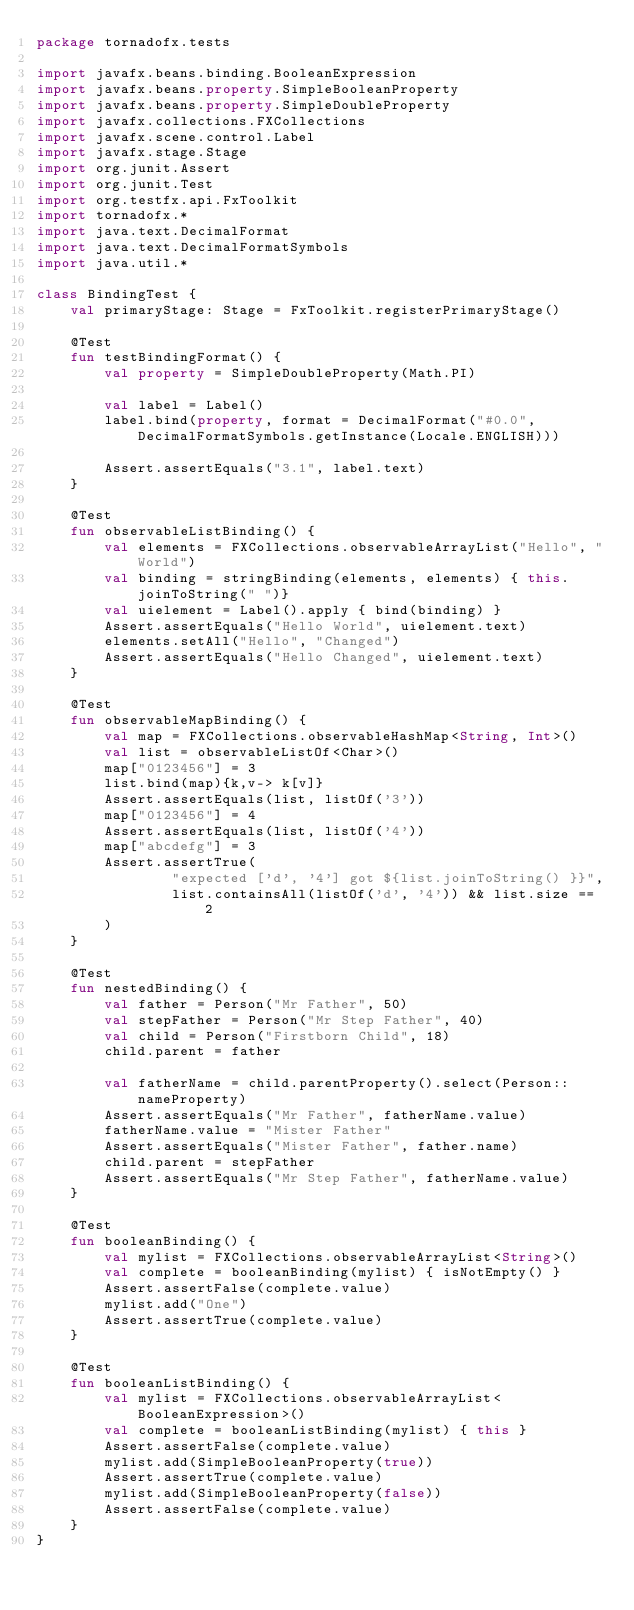<code> <loc_0><loc_0><loc_500><loc_500><_Kotlin_>package tornadofx.tests

import javafx.beans.binding.BooleanExpression
import javafx.beans.property.SimpleBooleanProperty
import javafx.beans.property.SimpleDoubleProperty
import javafx.collections.FXCollections
import javafx.scene.control.Label
import javafx.stage.Stage
import org.junit.Assert
import org.junit.Test
import org.testfx.api.FxToolkit
import tornadofx.*
import java.text.DecimalFormat
import java.text.DecimalFormatSymbols
import java.util.*

class BindingTest {
    val primaryStage: Stage = FxToolkit.registerPrimaryStage()

    @Test
    fun testBindingFormat() {
        val property = SimpleDoubleProperty(Math.PI)

        val label = Label()
        label.bind(property, format = DecimalFormat("#0.0", DecimalFormatSymbols.getInstance(Locale.ENGLISH)))

        Assert.assertEquals("3.1", label.text)
    }

    @Test
    fun observableListBinding() {
        val elements = FXCollections.observableArrayList("Hello", "World")
        val binding = stringBinding(elements, elements) { this.joinToString(" ")}
        val uielement = Label().apply { bind(binding) }
        Assert.assertEquals("Hello World", uielement.text)
        elements.setAll("Hello", "Changed")
        Assert.assertEquals("Hello Changed", uielement.text)
    }

    @Test
    fun observableMapBinding() {
        val map = FXCollections.observableHashMap<String, Int>()
        val list = observableListOf<Char>()
        map["0123456"] = 3
        list.bind(map){k,v-> k[v]}
        Assert.assertEquals(list, listOf('3'))
        map["0123456"] = 4
        Assert.assertEquals(list, listOf('4'))
        map["abcdefg"] = 3
        Assert.assertTrue(
                "expected ['d', '4'] got ${list.joinToString() }}",
                list.containsAll(listOf('d', '4')) && list.size == 2
        )
    }

    @Test
    fun nestedBinding() {
        val father = Person("Mr Father", 50)
        val stepFather = Person("Mr Step Father", 40)
        val child = Person("Firstborn Child", 18)
        child.parent = father

        val fatherName = child.parentProperty().select(Person::nameProperty)
        Assert.assertEquals("Mr Father", fatherName.value)
        fatherName.value = "Mister Father"
        Assert.assertEquals("Mister Father", father.name)
        child.parent = stepFather
        Assert.assertEquals("Mr Step Father", fatherName.value)
    }

    @Test
    fun booleanBinding() {
        val mylist = FXCollections.observableArrayList<String>()
        val complete = booleanBinding(mylist) { isNotEmpty() }
        Assert.assertFalse(complete.value)
        mylist.add("One")
        Assert.assertTrue(complete.value)
    }

    @Test
    fun booleanListBinding() {
        val mylist = FXCollections.observableArrayList<BooleanExpression>()
        val complete = booleanListBinding(mylist) { this }
        Assert.assertFalse(complete.value)
        mylist.add(SimpleBooleanProperty(true))
        Assert.assertTrue(complete.value)
        mylist.add(SimpleBooleanProperty(false))
        Assert.assertFalse(complete.value)
    }
}</code> 